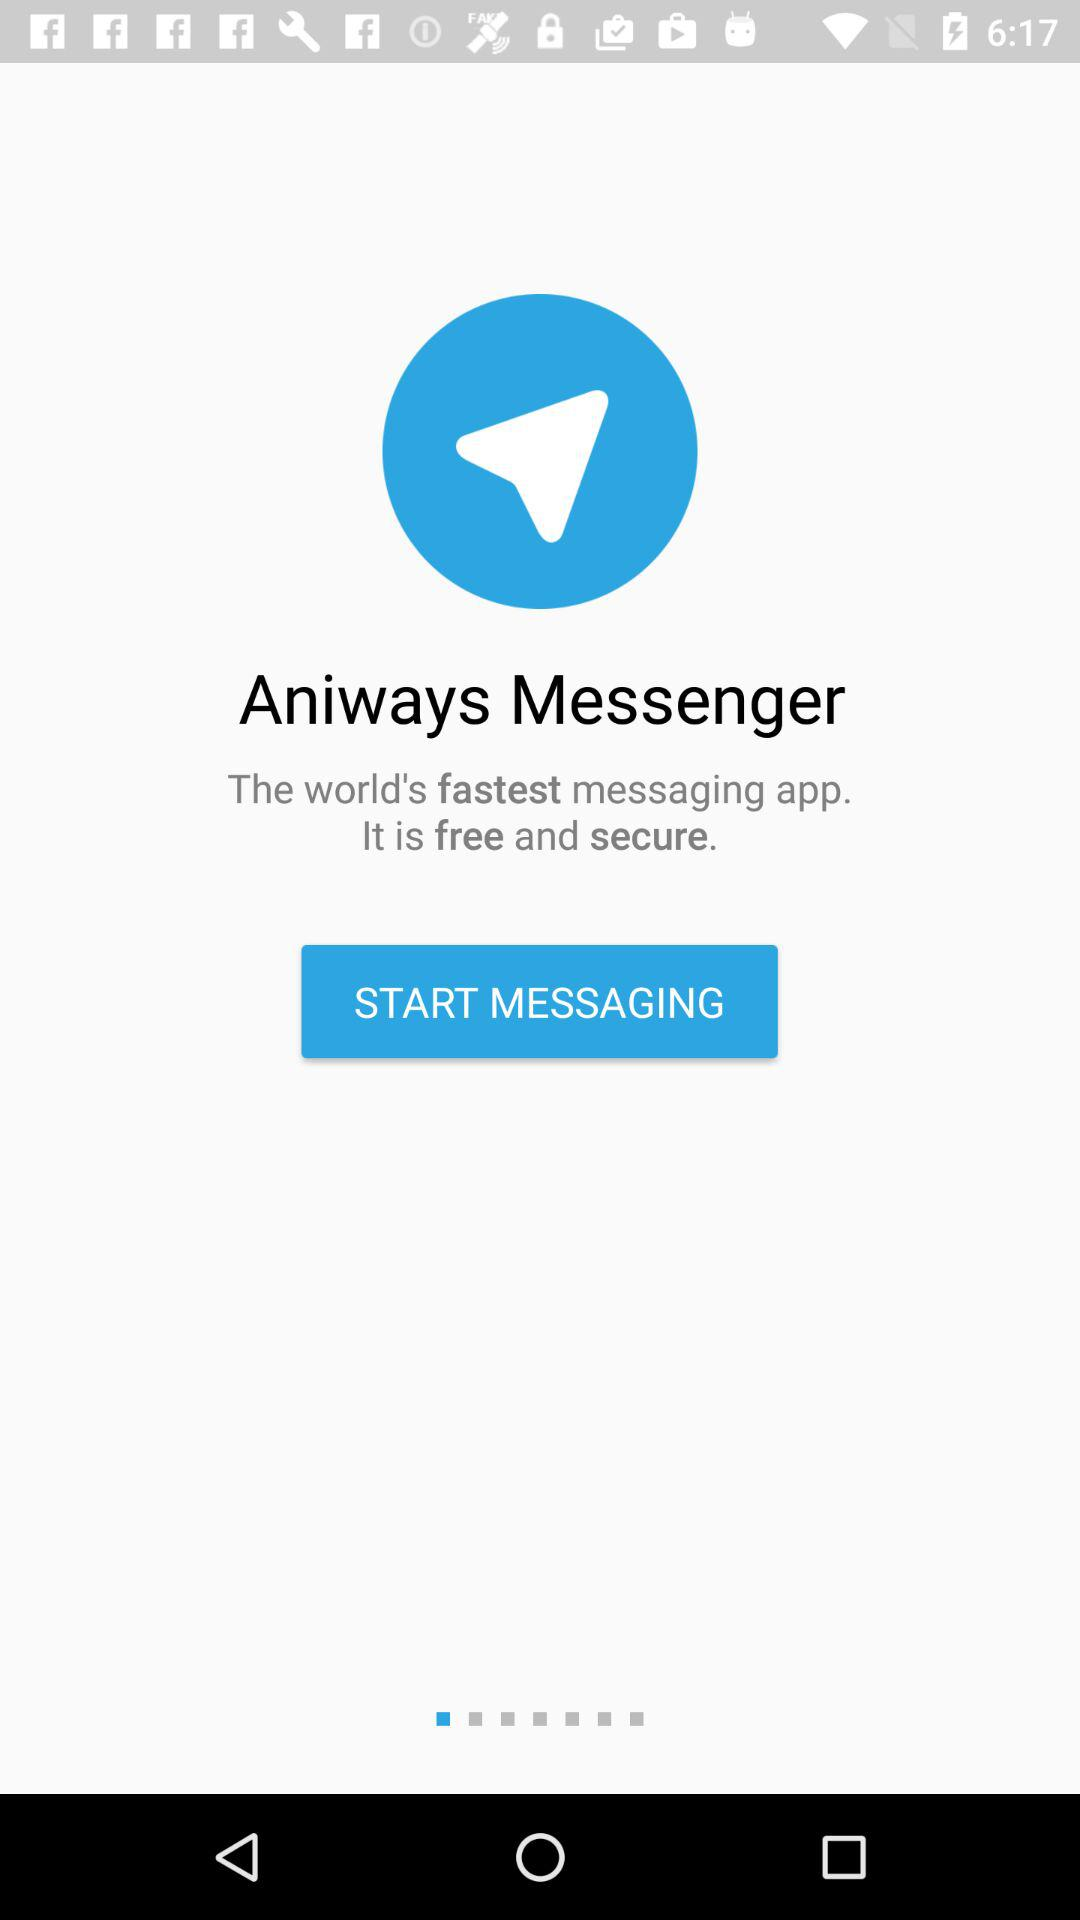What is the application name? The application name is "Aniways Messenger". 